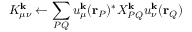Convert formula to latex. <formula><loc_0><loc_0><loc_500><loc_500>K _ { \mu \nu } ^ { k } \leftarrow \sum _ { P Q } u _ { \mu } ^ { k } ( r _ { P } ) ^ { * } X _ { P Q } ^ { k } u _ { \nu } ^ { k } ( r _ { Q } )</formula> 